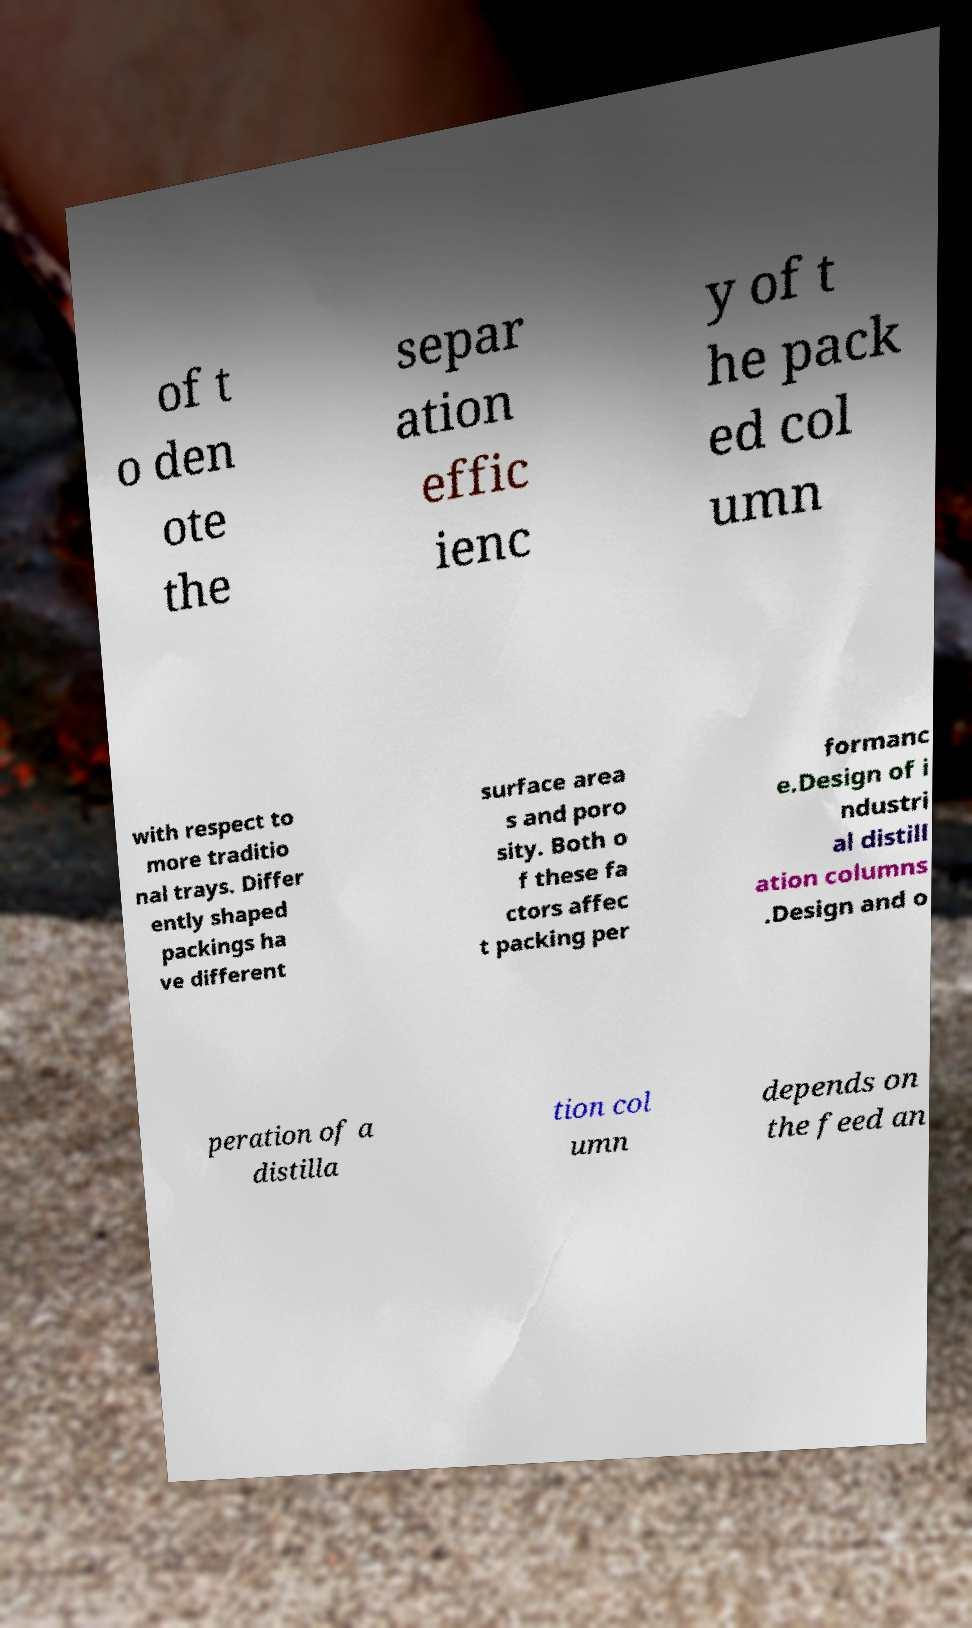Could you extract and type out the text from this image? of t o den ote the separ ation effic ienc y of t he pack ed col umn with respect to more traditio nal trays. Differ ently shaped packings ha ve different surface area s and poro sity. Both o f these fa ctors affec t packing per formanc e.Design of i ndustri al distill ation columns .Design and o peration of a distilla tion col umn depends on the feed an 